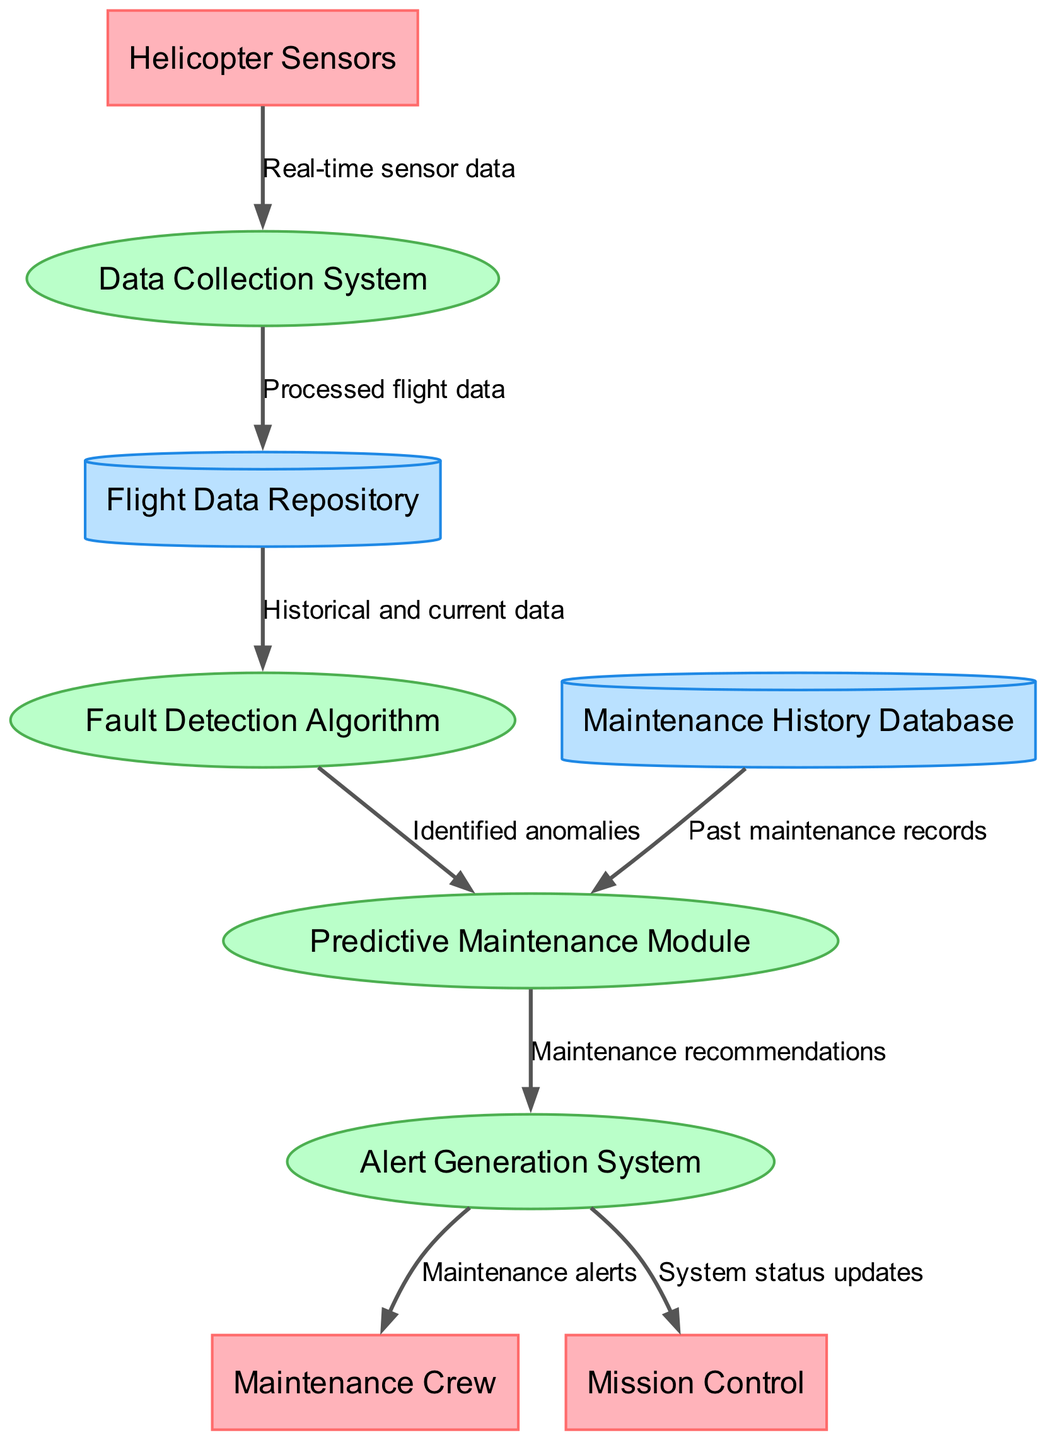What are the external entities in the diagram? The external entities listed in the diagram are the components that interact with the system. They provide inputs or receive outputs. In this case, they are Helicopter Sensors, Maintenance Crew, and Mission Control.
Answer: Helicopter Sensors, Maintenance Crew, Mission Control How many processes are in the system? The diagram includes a total of four processes, which are defined as functions or activities that transform inputs into outputs. These processes are the Data Collection System, Fault Detection Algorithm, Predictive Maintenance Module, and Alert Generation System.
Answer: 4 Which process receives data from the Helicopter Sensors? The data flows from Helicopter Sensors to the Data Collection System, indicating that this is the process responsible for gathering the real-time sensor data.
Answer: Data Collection System What is the final output of the Alert Generation System? The Alert Generation System produces two outputs: Maintenance alerts for the Maintenance Crew and System status updates for Mission Control. This indicates its role in communicating critical information regarding the helicopter's status.
Answer: Maintenance alerts, System status updates What type of data does the Fault Detection Algorithm use? The Fault Detection Algorithm accesses both historical and current data from the Flight Data Repository, as indicated by the data flow, to conduct its analysis and identify any anomalies.
Answer: Historical and current data Which module receives recommendations from the Predictive Maintenance Module? The Alert Generation System is the module that receives maintenance recommendations from the Predictive Maintenance Module, showing that it processes this information to generate alerts for relevant external entities.
Answer: Alert Generation System From which data store does the Predictive Maintenance Module get its input? The Predictive Maintenance Module receives input from the Maintenance History Database, allowing it to analyze past maintenance records for making maintenance recommendations.
Answer: Maintenance History Database How many data stores are represented in the diagram? There are two data stores depicted in the diagram, which are used to hold data for longer-term retrieval and processing. They are the Flight Data Repository and the Maintenance History Database.
Answer: 2 